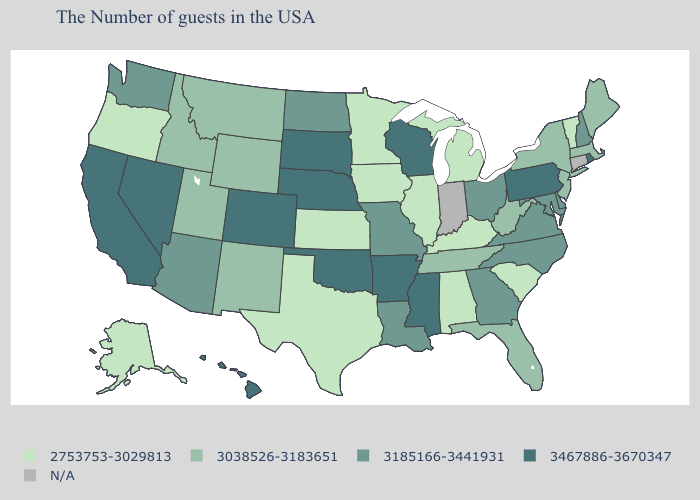What is the value of Connecticut?
Short answer required. N/A. What is the highest value in states that border Utah?
Concise answer only. 3467886-3670347. What is the value of Maryland?
Keep it brief. 3185166-3441931. What is the value of Washington?
Be succinct. 3185166-3441931. Does Nebraska have the highest value in the MidWest?
Concise answer only. Yes. Among the states that border North Dakota , does Minnesota have the lowest value?
Short answer required. Yes. Name the states that have a value in the range 3185166-3441931?
Give a very brief answer. New Hampshire, Delaware, Maryland, Virginia, North Carolina, Ohio, Georgia, Louisiana, Missouri, North Dakota, Arizona, Washington. Name the states that have a value in the range 3038526-3183651?
Give a very brief answer. Maine, Massachusetts, New York, New Jersey, West Virginia, Florida, Tennessee, Wyoming, New Mexico, Utah, Montana, Idaho. Among the states that border Maryland , which have the highest value?
Short answer required. Pennsylvania. What is the value of Ohio?
Give a very brief answer. 3185166-3441931. Name the states that have a value in the range 3185166-3441931?
Concise answer only. New Hampshire, Delaware, Maryland, Virginia, North Carolina, Ohio, Georgia, Louisiana, Missouri, North Dakota, Arizona, Washington. Among the states that border Illinois , which have the lowest value?
Be succinct. Kentucky, Iowa. Name the states that have a value in the range 3467886-3670347?
Concise answer only. Rhode Island, Pennsylvania, Wisconsin, Mississippi, Arkansas, Nebraska, Oklahoma, South Dakota, Colorado, Nevada, California, Hawaii. 